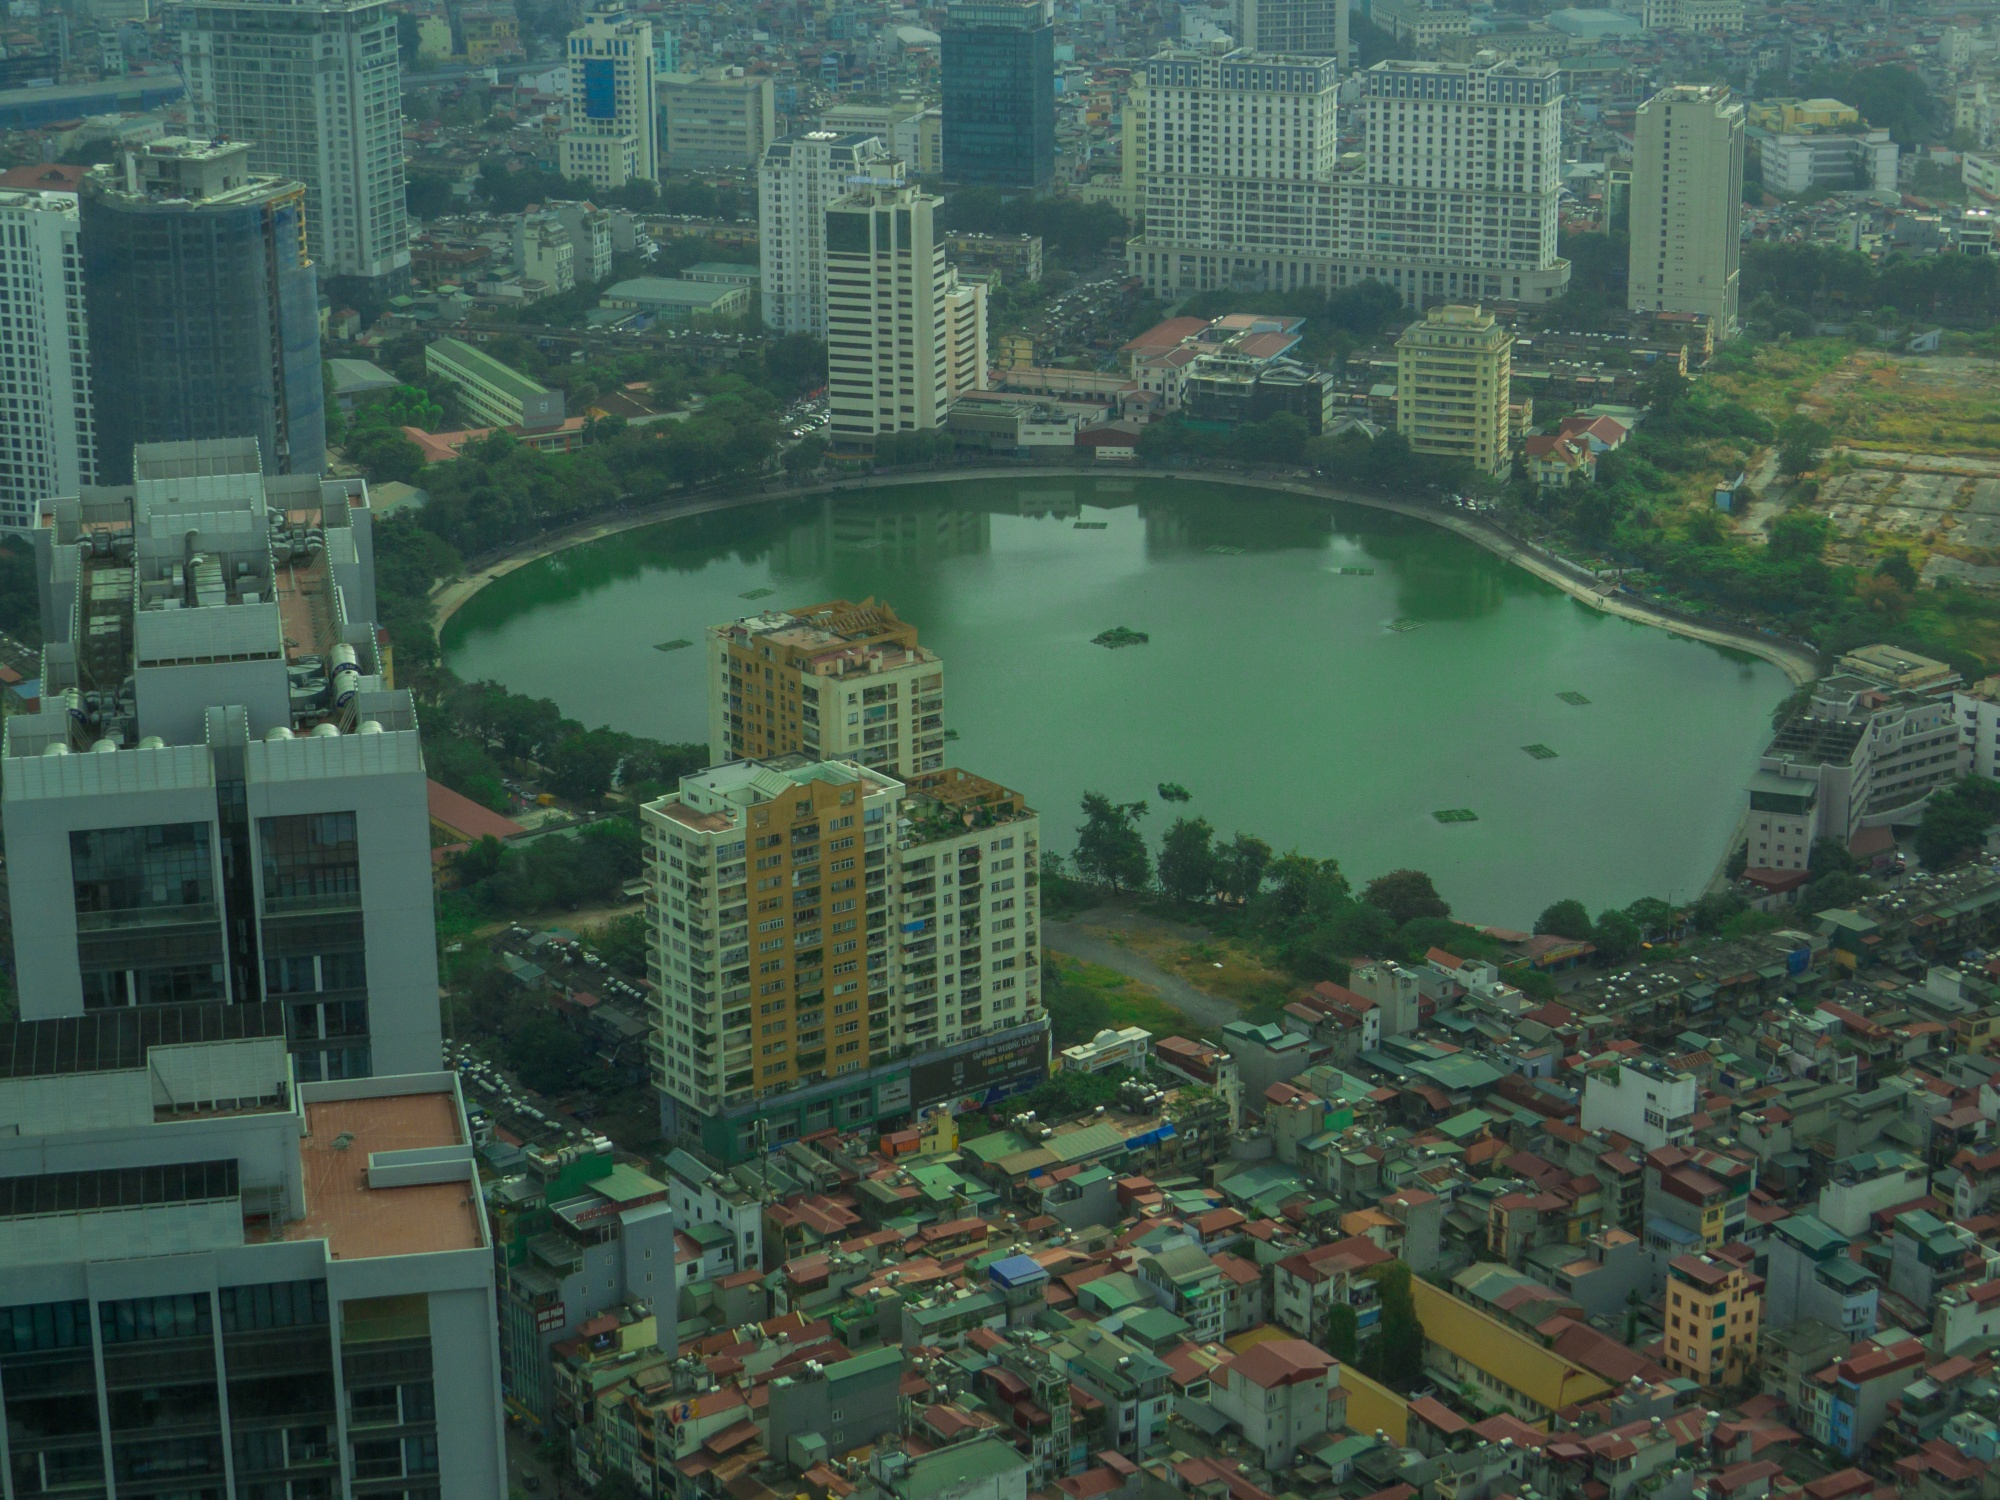If an art installation were to be displayed on the small island in the lake, what would it depict and why? An art installation on the small island in the lake could symbolize the harmony between urban development and nature. Imagine a towering sculpture made from recycled materials, representing a sprawling tree whose branches are woven with LED lights. These lights change color to reflect the time of day, weather conditions, or even seasonal changes, blending art with technology and the natural environment. This installation would draw attention to themes of sustainability, the balance between progress and preservation, and the interconnection of human life with the natural world. It would serve not only as a visual centerpiece but also as an educational and inspirational landmark, encouraging viewers to reflect on their relationship with the environment and the importance of sustainable living. Can you imagine how this spot would look during an annual city festival? During an annual city festival, the area around the lake would be bursting with color, light, and activity. The buildings around the lake would be adorned with festive banners, flags, and twinkling lights. Stalls offering local food, crafts, and art would line the pathways, inviting visitors to explore. The lake itself would be the stage for various events - perhaps a floating lantern display, where thousands of lanterns are released onto the water, illuminating it with a mesmerizing glow. A live music performance on a floating stage could entertain crowds, with melodies echoing across the lake. The small island might host an elaborate fireworks display, each burst of color reflected in the water, adding to the spectacle. Families, friends, and tourists alike would gather to celebrate, turning the scene into a vibrant and joyous expression of community spirit. 